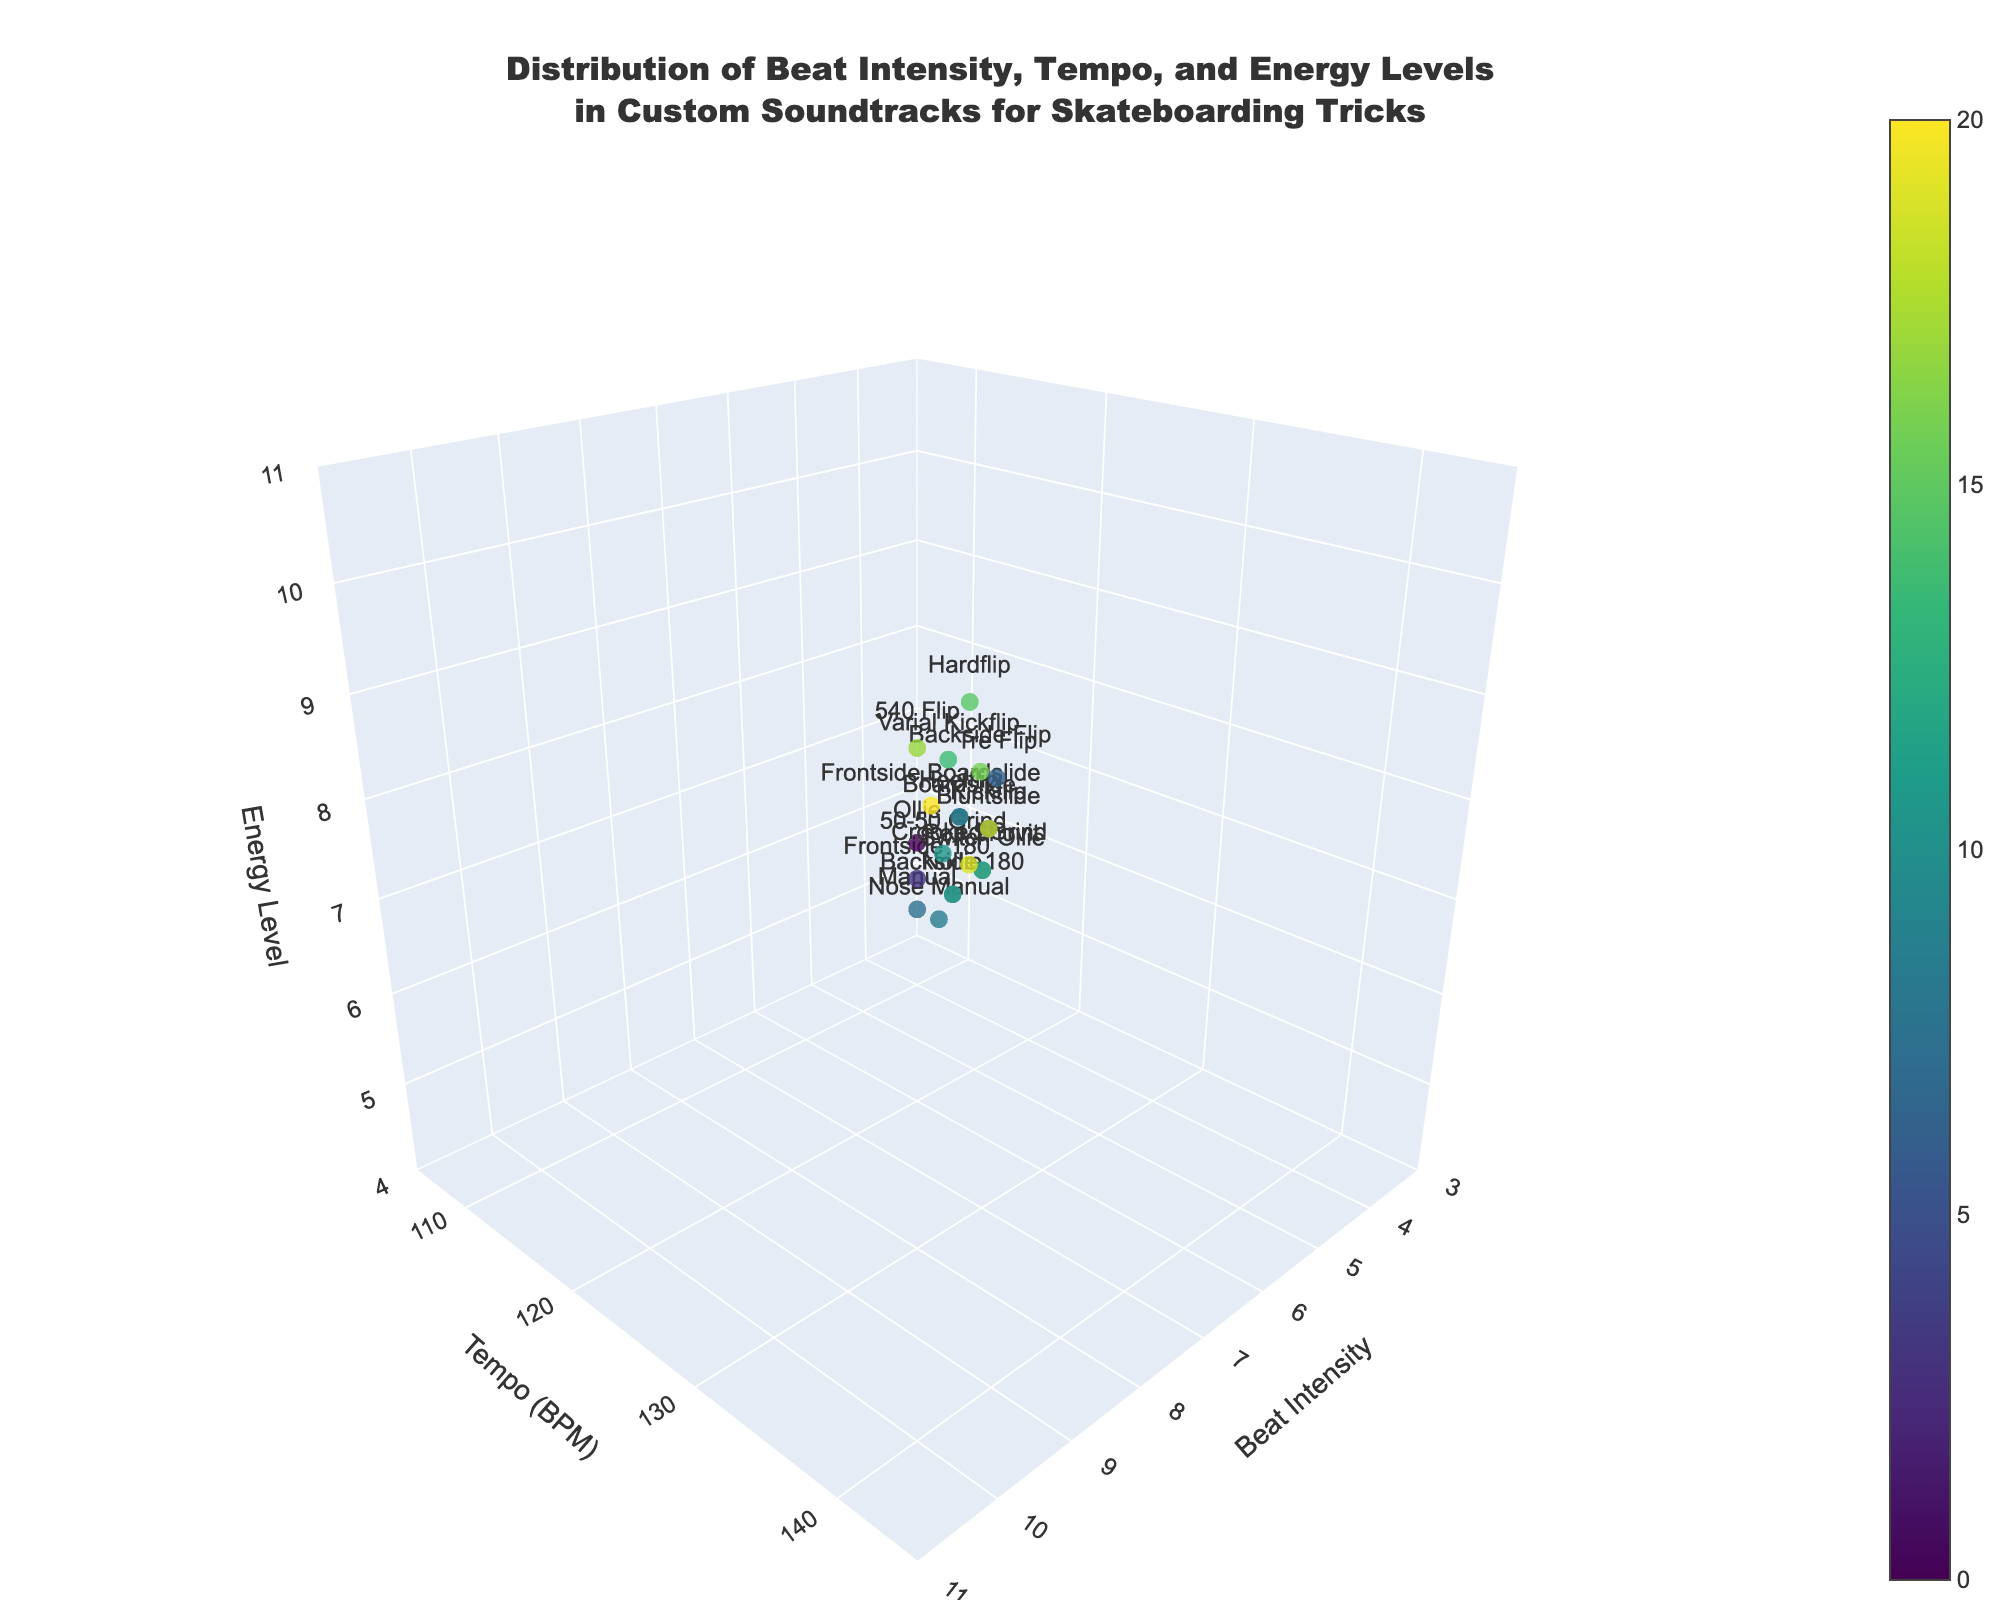Do all trick categories have unique beat intensity values? To verify if all trick categories have unique values for beat intensity, we need to check if each trick category listed has a distinct beat intensity without any repetitions. By scanning the visual representation and checking against the table, it looks like beat intensity values are repeated for different trick categories.
Answer: No Which trick category has the highest energy level? The highest energy level can be found by locating the point on the z-axis with the highest value and identifying the corresponding trick category. By examining the plot, the trick category with the maximum energy level appears at z=10. According to the data, the trick categories that match are "Hardflip" and "540 Flip".
Answer: Hardflip and 540 Flip What's the difference in tempo between the "Hardflip" and the "Manual"? First, identify the tempo for both the "Hardflip" and the "Manual" from the plot. "Hardflip" has a tempo of 138 BPM, and "Manual" has a tempo of 110 BPM. The difference is calculated by subtracting the tempo of the lower value from the higher value: 138 BPM - 110 BPM = 28 BPM.
Answer: 28 BPM Compare the tempo of "Kickflip" and "Nose Manual"; which one is higher? By checking the tempo values for both "Kickflip" and "Nose Manual" on the plot, we see that "Kickflip" has a tempo of 130 BPM, while "Nose Manual" has a tempo of 112 BPM. Therefore, "Kickflip" has the higher tempo.
Answer: Kickflip Which trick categories have the same beat intensity of 7? To find which categories have a beat intensity of 7, we should look for points at x=7 and observe the corresponding trick categories on the plot. According to the plot, the trick categories are Kickflip, Heelflip, Boardslide, Frontside Boardslide, Bluntslide.
Answer: Kickflip, Heelflip, Boardslide, Frontside Boardslide, Bluntslide What are the tempo ranges depicted in the plot? To determine the tempo ranges, we need to observe the y-axis of the plot. The plot shows the range starting from around 105 BPM up to approximately 145 BPM.
Answer: 105 to 145 BPM Are there any trick categories with the same energy level and beat intensity combination? To determine this, we must check for points that have identical x (Beat Intensity) and z (Energy Level) coordinates on the plot. By closely examining, we see that there are no exact matching coordinates in both beat intensity and energy level for two different trick categories.
Answer: No Which trick has the lowest tempo and what's its beat intensity and energy level? By identifying the point with the smallest y value (tempo) from the plot, the trick with the lowest tempo is "Manual," which has a tempo of 110 BPM. The beat intensity for "Manual" is 4, and the energy level is 5.
Answer: Manual, Beat Intensity: 4, Energy Level: 5 